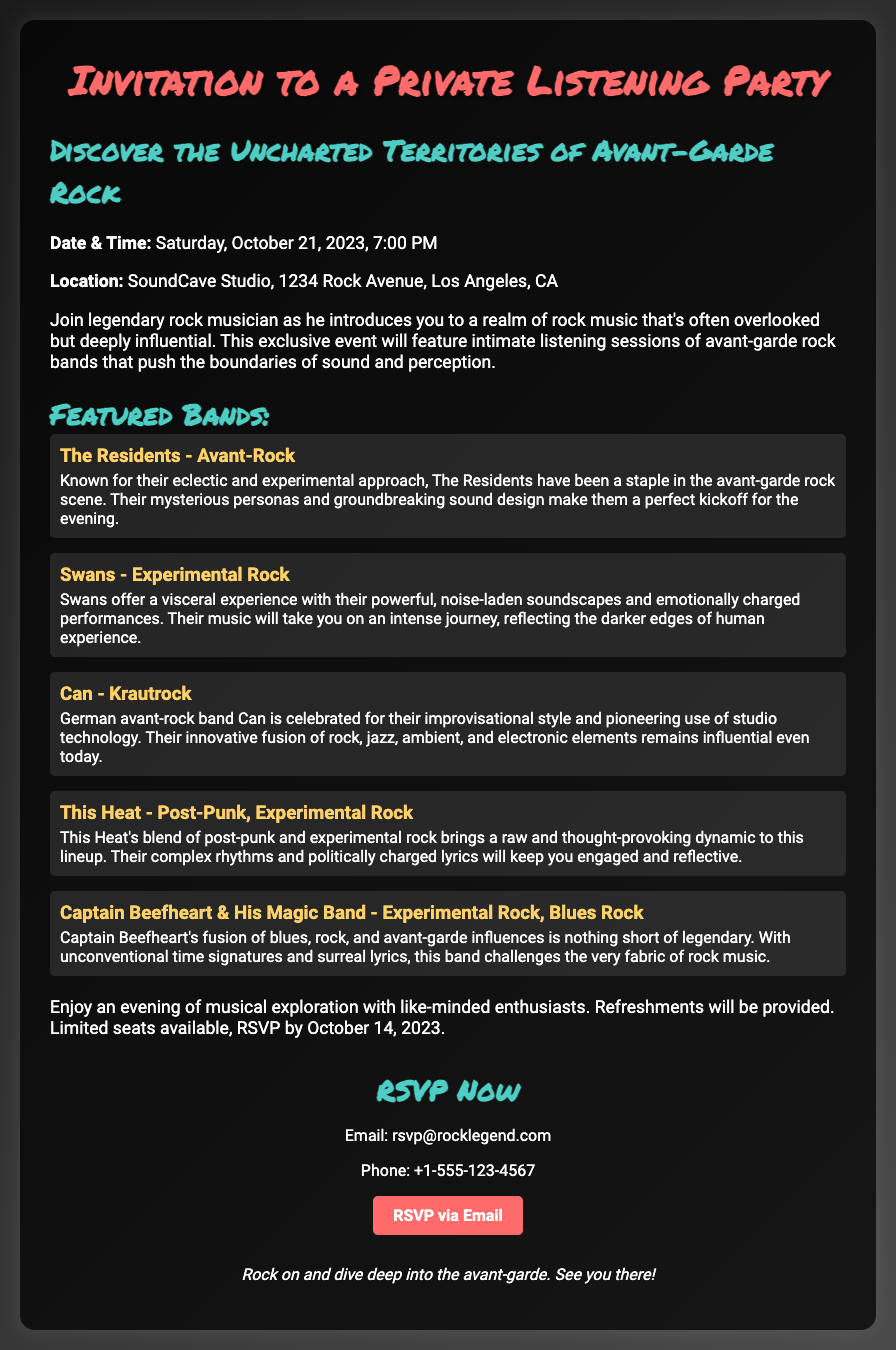What date is the listening party? The date of the listening party is explicitly mentioned in the document.
Answer: October 21, 2023 What is the location of the event? The document provides a specific address for the event's location.
Answer: SoundCave Studio, 1234 Rock Avenue, Los Angeles, CA How many featured bands are listed? The number of featured bands can be counted from the document.
Answer: Five What is the RSVP deadline? The deadline for RSVPing is stated in the details section of the document.
Answer: October 14, 2023 Which band is known for their improvisational style? This information is found in the description provided for Can.
Answer: Can What genre does The Residents belong to? The genre of The Residents is specified in the document.
Answer: Avant-Rock Why should one attend the listening party? The document mentions the purpose of the event, highlighting its unique aspects.
Answer: Musical exploration What will be provided at the event? The document states what will be available during the listening party.
Answer: Refreshments 